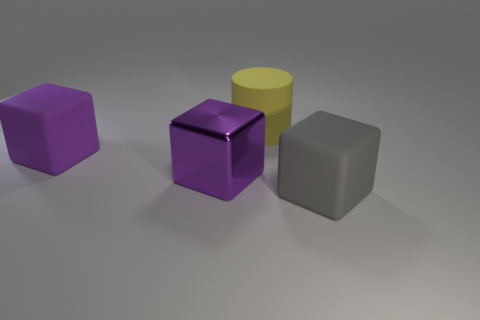What can you infer about the setting or context based on the image? The image seems to be a staged scene, potentially for the purpose of showcasing the objects or as a rendering to study shapes and materials. The plain background and absence of any distinct features like horizons or objects suggest it is not meant to represent a real-life setting, but rather a controlled environment, such as a digital simulation or a photographer’s lightbox. 